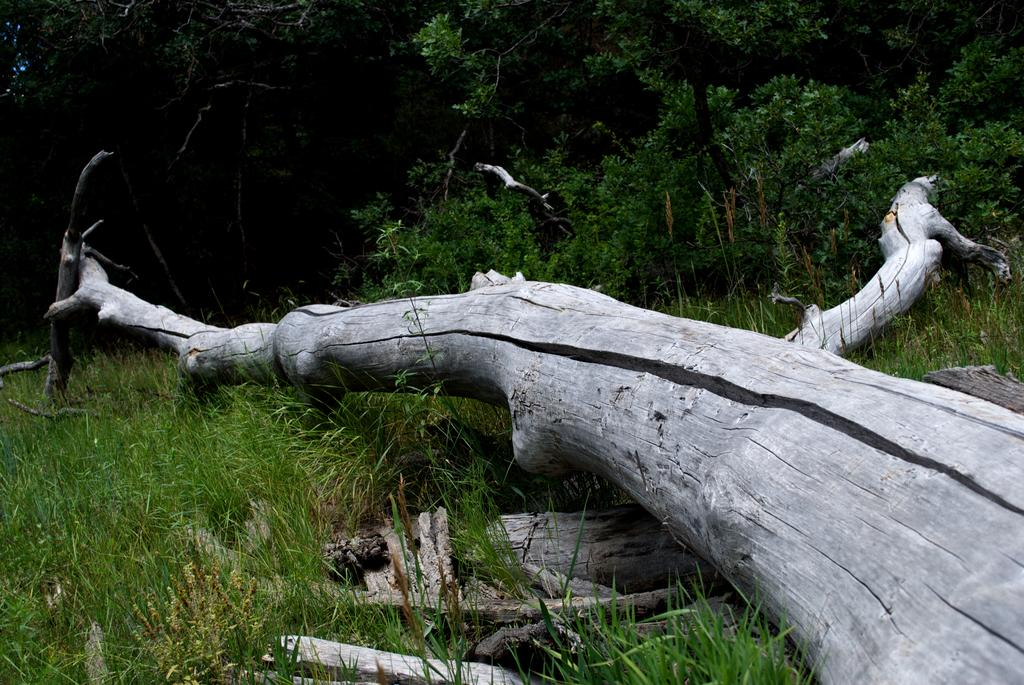What type of material are the objects in the image made of? The objects in the image are made of wood. Where are the wooden objects located? The wooden objects are on the grass. What can be seen in the background of the image? There are trees in the background of the image. What type of wine is being served by the sister in the image? There is no wine or sister present in the image; it features wooden objects on the grass with trees in the background. 